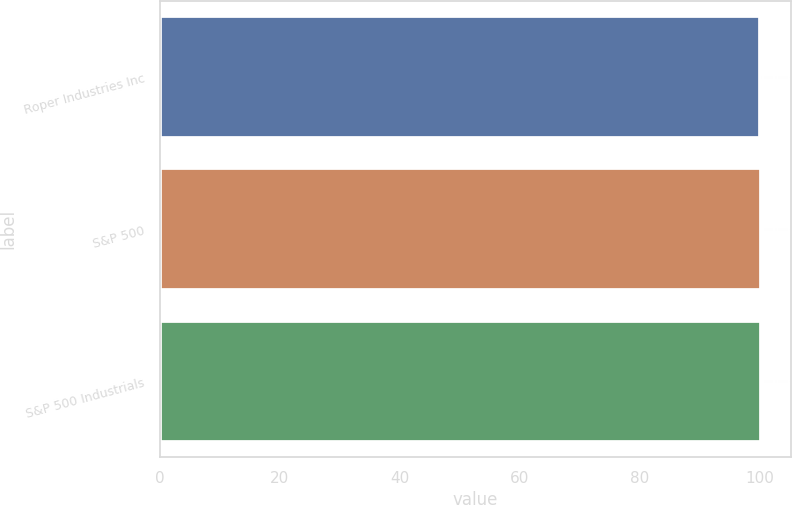Convert chart. <chart><loc_0><loc_0><loc_500><loc_500><bar_chart><fcel>Roper Industries Inc<fcel>S&P 500<fcel>S&P 500 Industrials<nl><fcel>100<fcel>100.1<fcel>100.2<nl></chart> 